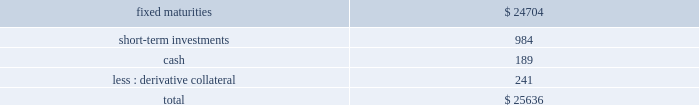Hlikk has four revolving credit facilities in support of operations .
Two of the credit facilities have no amounts drawn as of december 31 , 2013 with borrowing limits of approximately a55 billion , or $ 48 each , and individually have expiration dates of january 5 , 2015 and september 30 , 2014 .
In december 2013 , hlikk entered into two new revolving credit facility agreements with two japanese banks in order to finance certain withholding taxes on mutual fund gains , that are subsequently credited when hlikk files its 2019 income tax returns .
At december 31 , 2013 , hlikk had drawn the total borrowing limits of a55 billion , or $ 48 , and a520 billion , or $ 190 on these credit facilities .
The a55 billion credit facility accrues interest at a variable rate based on the one month tokyo interbank offering rate ( tibor ) plus 3 bps , which as of december 31 , 2013 the interest rate was 15 bps , and the a520 billion credit facility accrues interest at a variable rate based on tibor plus 3 bps , or the actual cost of funding , which as of december 31 , 2013 the interest rate was 20 bps .
Both of the credit facilities expire on september 30 , 2014 .
Derivative commitments certain of the company 2019s derivative agreements contain provisions that are tied to the financial strength ratings of the individual legal entity that entered into the derivative agreement as set by nationally recognized statistical rating agencies .
If the legal entity 2019s financial strength were to fall below certain ratings , the counterparties to the derivative agreements could demand immediate and ongoing full collateralization and in certain instances demand immediate settlement of all outstanding derivative positions traded under each impacted bilateral agreement .
The settlement amount is determined by netting the derivative positions transacted under each agreement .
If the termination rights were to be exercised by the counterparties , it could impact the legal entity 2019s ability to conduct hedging activities by increasing the associated costs and decreasing the willingness of counterparties to transact with the legal entity .
The aggregate fair value of all derivative instruments with credit-risk-related contingent features that are in a net liability position as of december 31 , 2013 was $ 1.2 billion .
Of this $ 1.2 billion the legal entities have posted collateral of $ 1.4 billion in the normal course of business .
In addition , the company has posted collateral of $ 44 associated with a customized gmwb derivative .
Based on derivative market values as of december 31 , 2013 , a downgrade of one level below the current financial strength ratings by either moody 2019s or s&p could require approximately an additional $ 12 to be posted as collateral .
Based on derivative market values as of december 31 , 2013 , a downgrade by either moody 2019s or s&p of two levels below the legal entities 2019 current financial strength ratings could require approximately an additional $ 33 of assets to be posted as collateral .
These collateral amounts could change as derivative market values change , as a result of changes in our hedging activities or to the extent changes in contractual terms are negotiated .
The nature of the collateral that we would post , if required , would be primarily in the form of u.s .
Treasury bills , u.s .
Treasury notes and government agency securities .
As of december 31 , 2013 , the aggregate notional amount and fair value of derivative relationships that could be subject to immediate termination in the event of rating agency downgrades to either bbb+ or baa1 was $ 536 and $ ( 17 ) , respectively .
Insurance operations current and expected patterns of claim frequency and severity or surrenders may change from period to period but continue to be within historical norms and , therefore , the company 2019s insurance operations 2019 current liquidity position is considered to be sufficient to meet anticipated demands over the next twelve months , including any obligations related to the company 2019s restructuring activities .
For a discussion and tabular presentation of the company 2019s current contractual obligations by period , refer to off-balance sheet arrangements and aggregate contractual obligations within the capital resources and liquidity section of the md&a .
The principal sources of operating funds are premiums , fees earned from assets under management and investment income , while investing cash flows originate from maturities and sales of invested assets .
The primary uses of funds are to pay claims , claim adjustment expenses , commissions and other underwriting expenses , to purchase new investments and to make dividend payments to the hfsg holding company .
The company 2019s insurance operations consist of property and casualty insurance products ( collectively referred to as 201cproperty & casualty operations 201d ) and life insurance and legacy annuity products ( collectively referred to as 201clife operations 201d ) .
Property & casualty operations property & casualty operations holds fixed maturity securities including a significant short-term investment position ( securities with maturities of one year or less at the time of purchase ) to meet liquidity needs .
As of december 31 , 2013 , property & casualty operations 2019 fixed maturities , short-term investments , and cash are summarized as follows: .

What percent of total amount is held as cash? 
Computations: (189 / 25636)
Answer: 0.00737. 